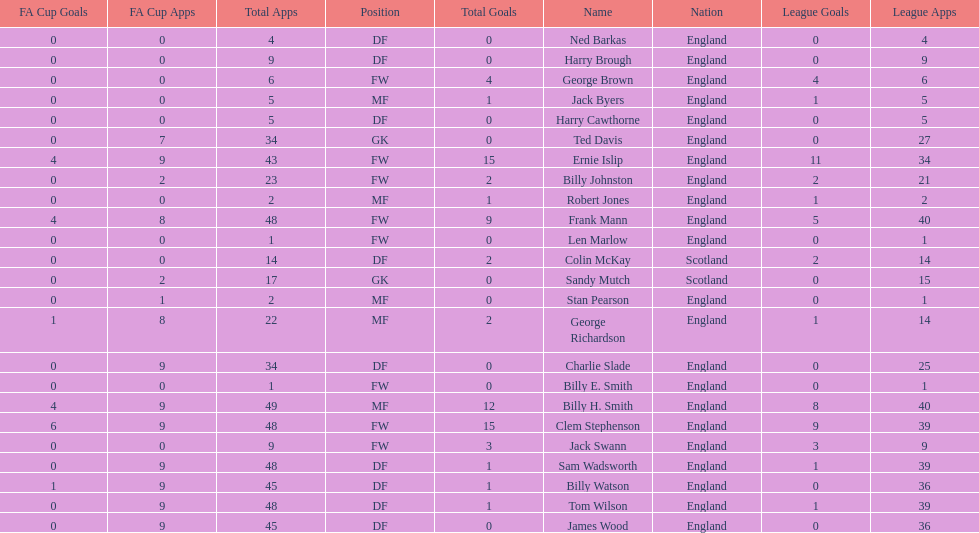What are the number of league apps ted davis has? 27. 